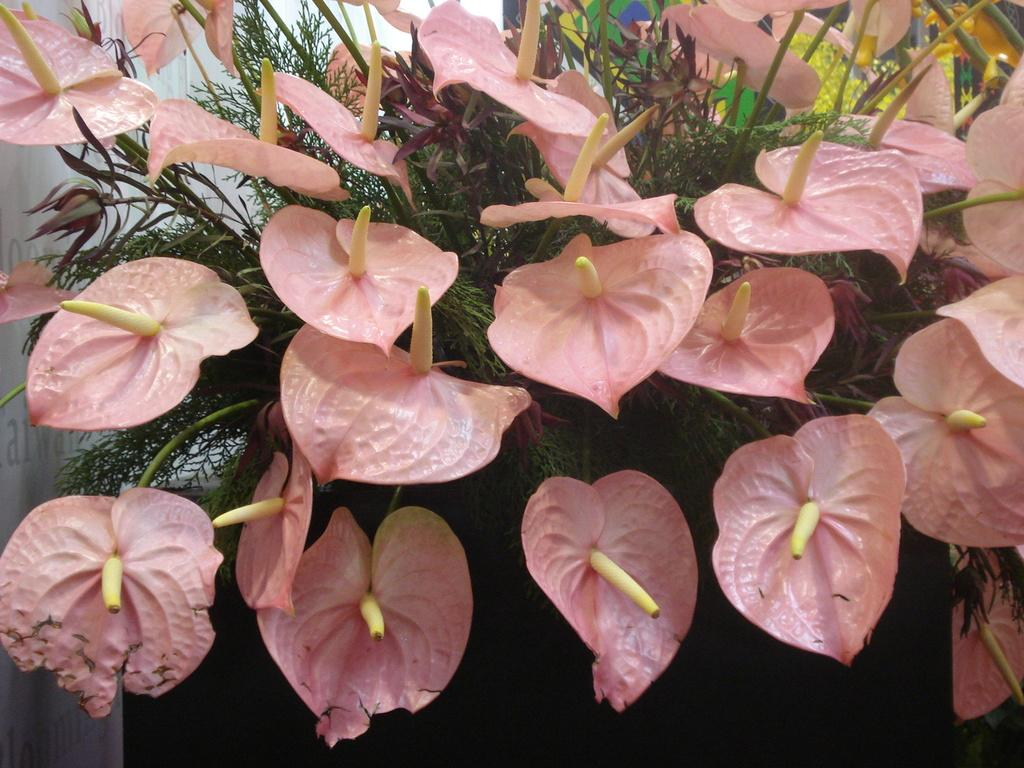What type of plant life is visible in the image? There are flowers in the image. What part of the flowers can be seen in the image? There are leaves on the stems in the image. What is located to the left in the image? There is a wall to the left in the image. What is written or depicted on the wall? There is text on the wall in the image. Can you measure the length of the blade in the image? There is no blade present in the image; it features flowers and a wall with text. 